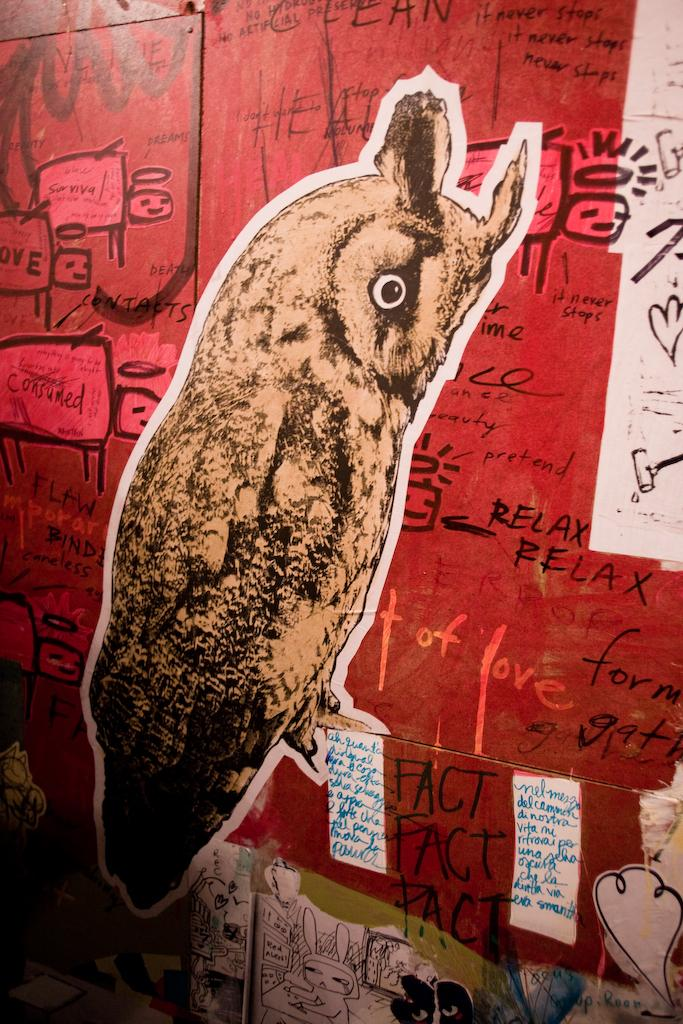What can be seen in the image that supports or holds something? There are posts in the image that support or hold something. What type of living creature is present in the image? There is an animal in the image. What can be found in the image that conveys information or meaning? There is text in the image. What else can be seen in the image besides the posts, animal, and text? There are objects in the image. What type of vest is the animal wearing in the image? There is no vest present in the image, and the animal is not wearing any clothing. What time of day is depicted in the image, based on the hour shown? There is no hour or time reference present in the image. 